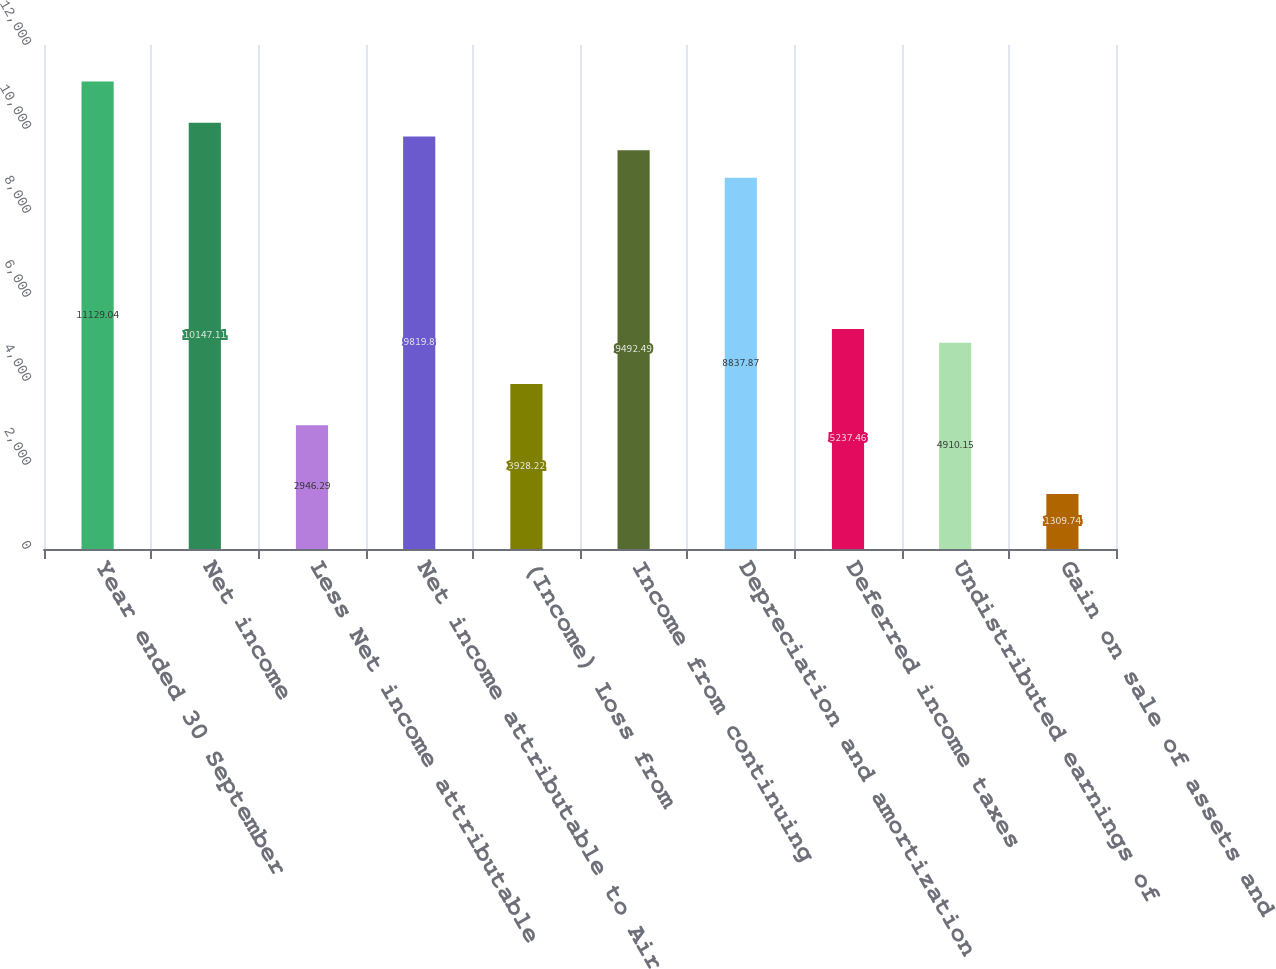Convert chart to OTSL. <chart><loc_0><loc_0><loc_500><loc_500><bar_chart><fcel>Year ended 30 September<fcel>Net income<fcel>Less Net income attributable<fcel>Net income attributable to Air<fcel>(Income) Loss from<fcel>Income from continuing<fcel>Depreciation and amortization<fcel>Deferred income taxes<fcel>Undistributed earnings of<fcel>Gain on sale of assets and<nl><fcel>11129<fcel>10147.1<fcel>2946.29<fcel>9819.8<fcel>3928.22<fcel>9492.49<fcel>8837.87<fcel>5237.46<fcel>4910.15<fcel>1309.74<nl></chart> 